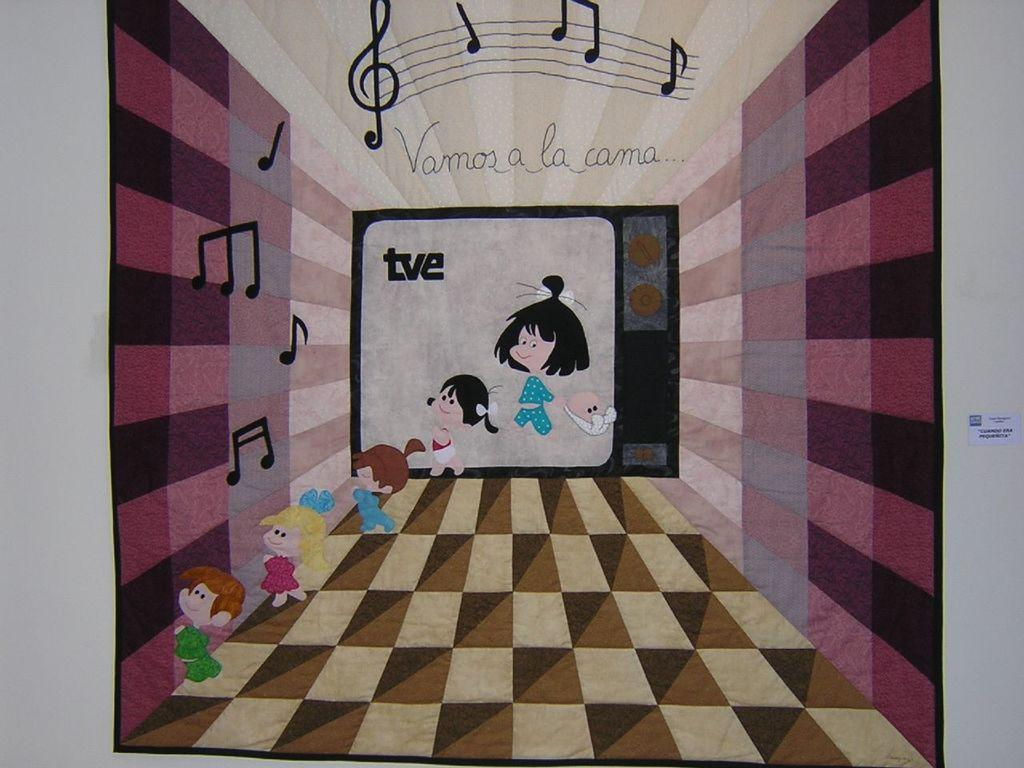<image>
Write a terse but informative summary of the picture. A cartoon features the caption "vamos a la cama." 